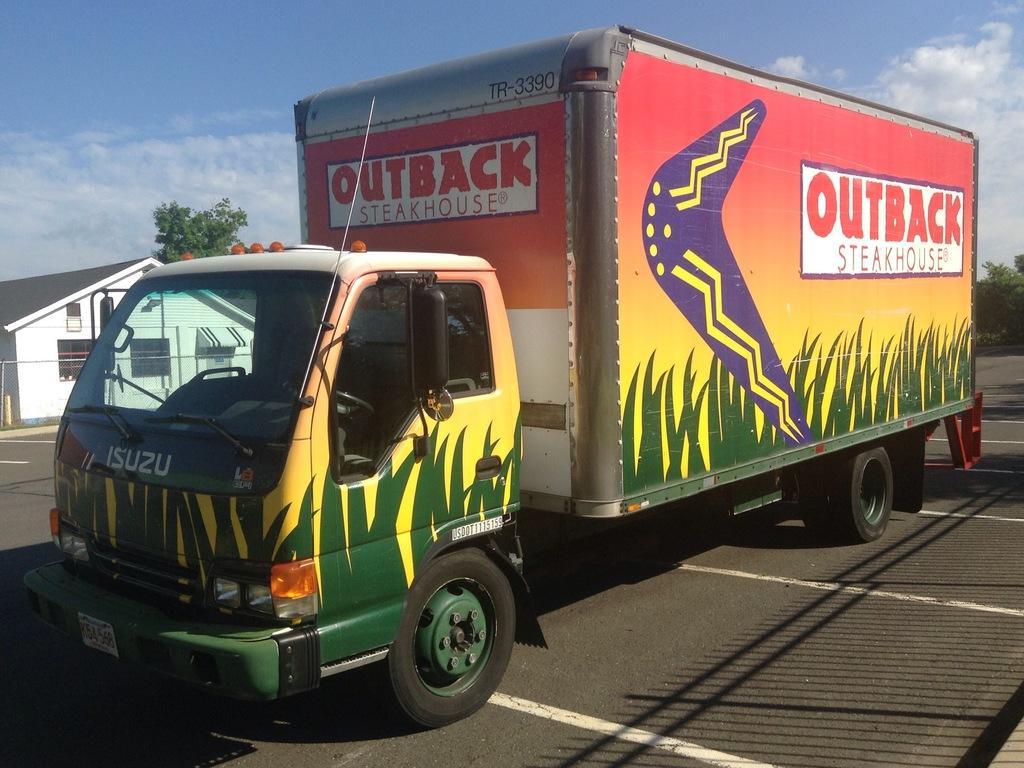Describe this image in one or two sentences. In this image I can see a road in the front and on it I can see few white lines, few shadows and a truck. I can also see something is written on the truck. In the background I can see few trees, in white colour house, clouds and the sky. 